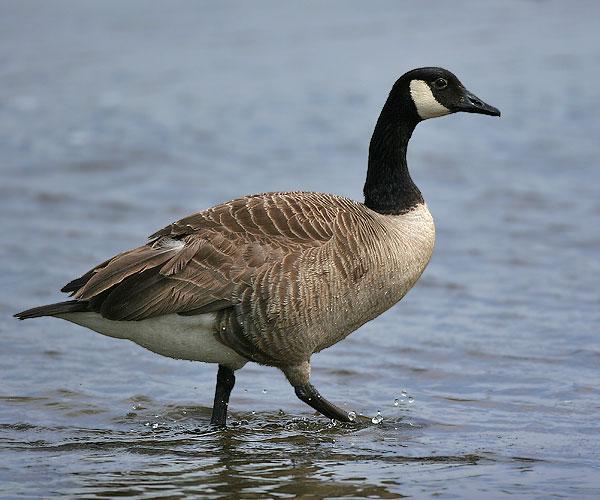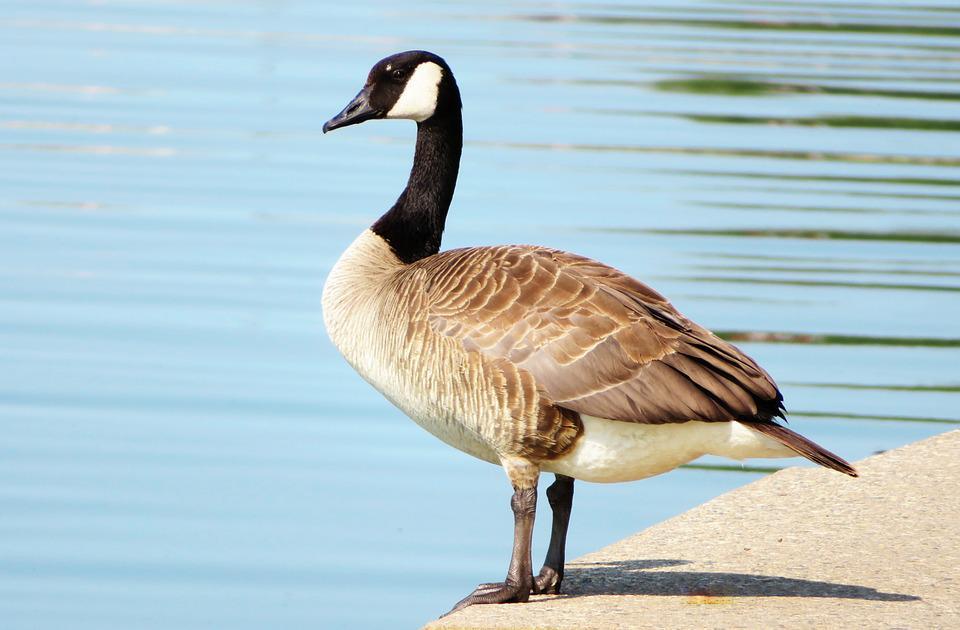The first image is the image on the left, the second image is the image on the right. Analyze the images presented: Is the assertion "the bird on the left faces right and the bird on the right faces left" valid? Answer yes or no. Yes. 